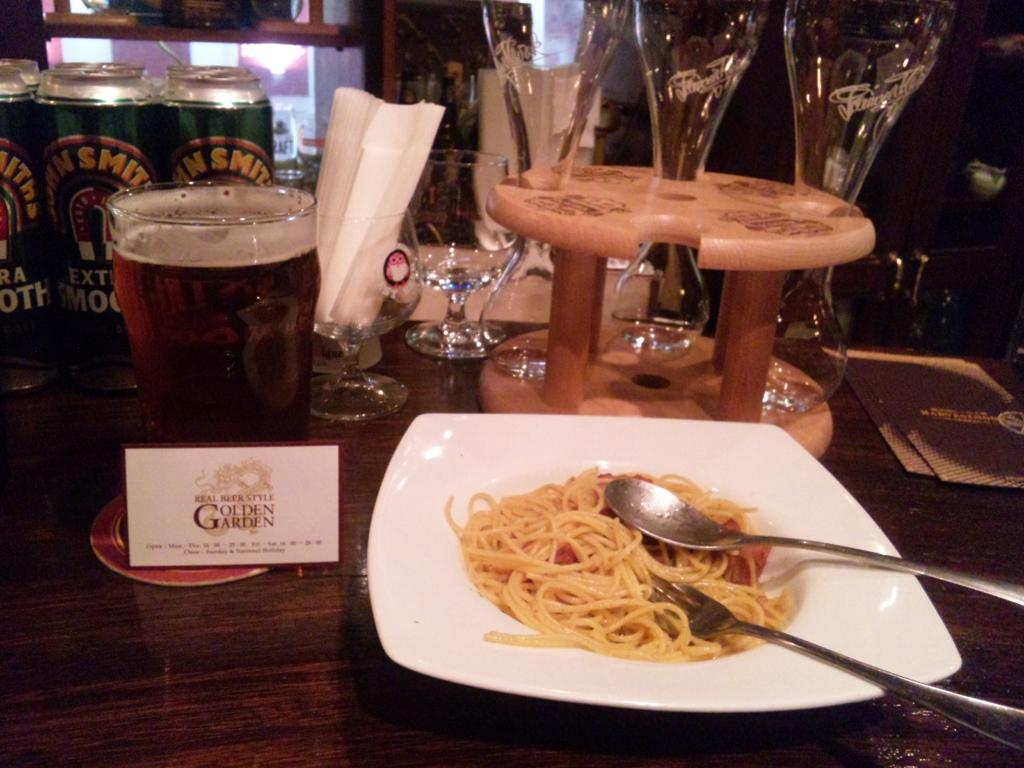What is on the plate in the image? There is food in the plate in the image. What utensils are visible in the image? There is a fork and a spoon in the image. What type of drinkware is present in the image? There are glasses in the image, including a glass with beer. What might be used for cleaning or wiping in the image? Napkins are present in the image for cleaning or wiping. What additional items can be seen in the image? There are cans on the side in the image. Can you see a pig playing on the playground in the image? There is no pig or playground present in the image. What is the condition of the person's throat in the image? There is no reference to a person or their throat in the image. 